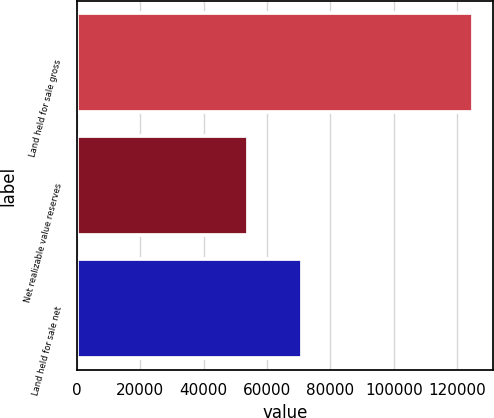<chart> <loc_0><loc_0><loc_500><loc_500><bar_chart><fcel>Land held for sale gross<fcel>Net realizable value reserves<fcel>Land held for sale net<nl><fcel>124919<fcel>53864<fcel>71055<nl></chart> 